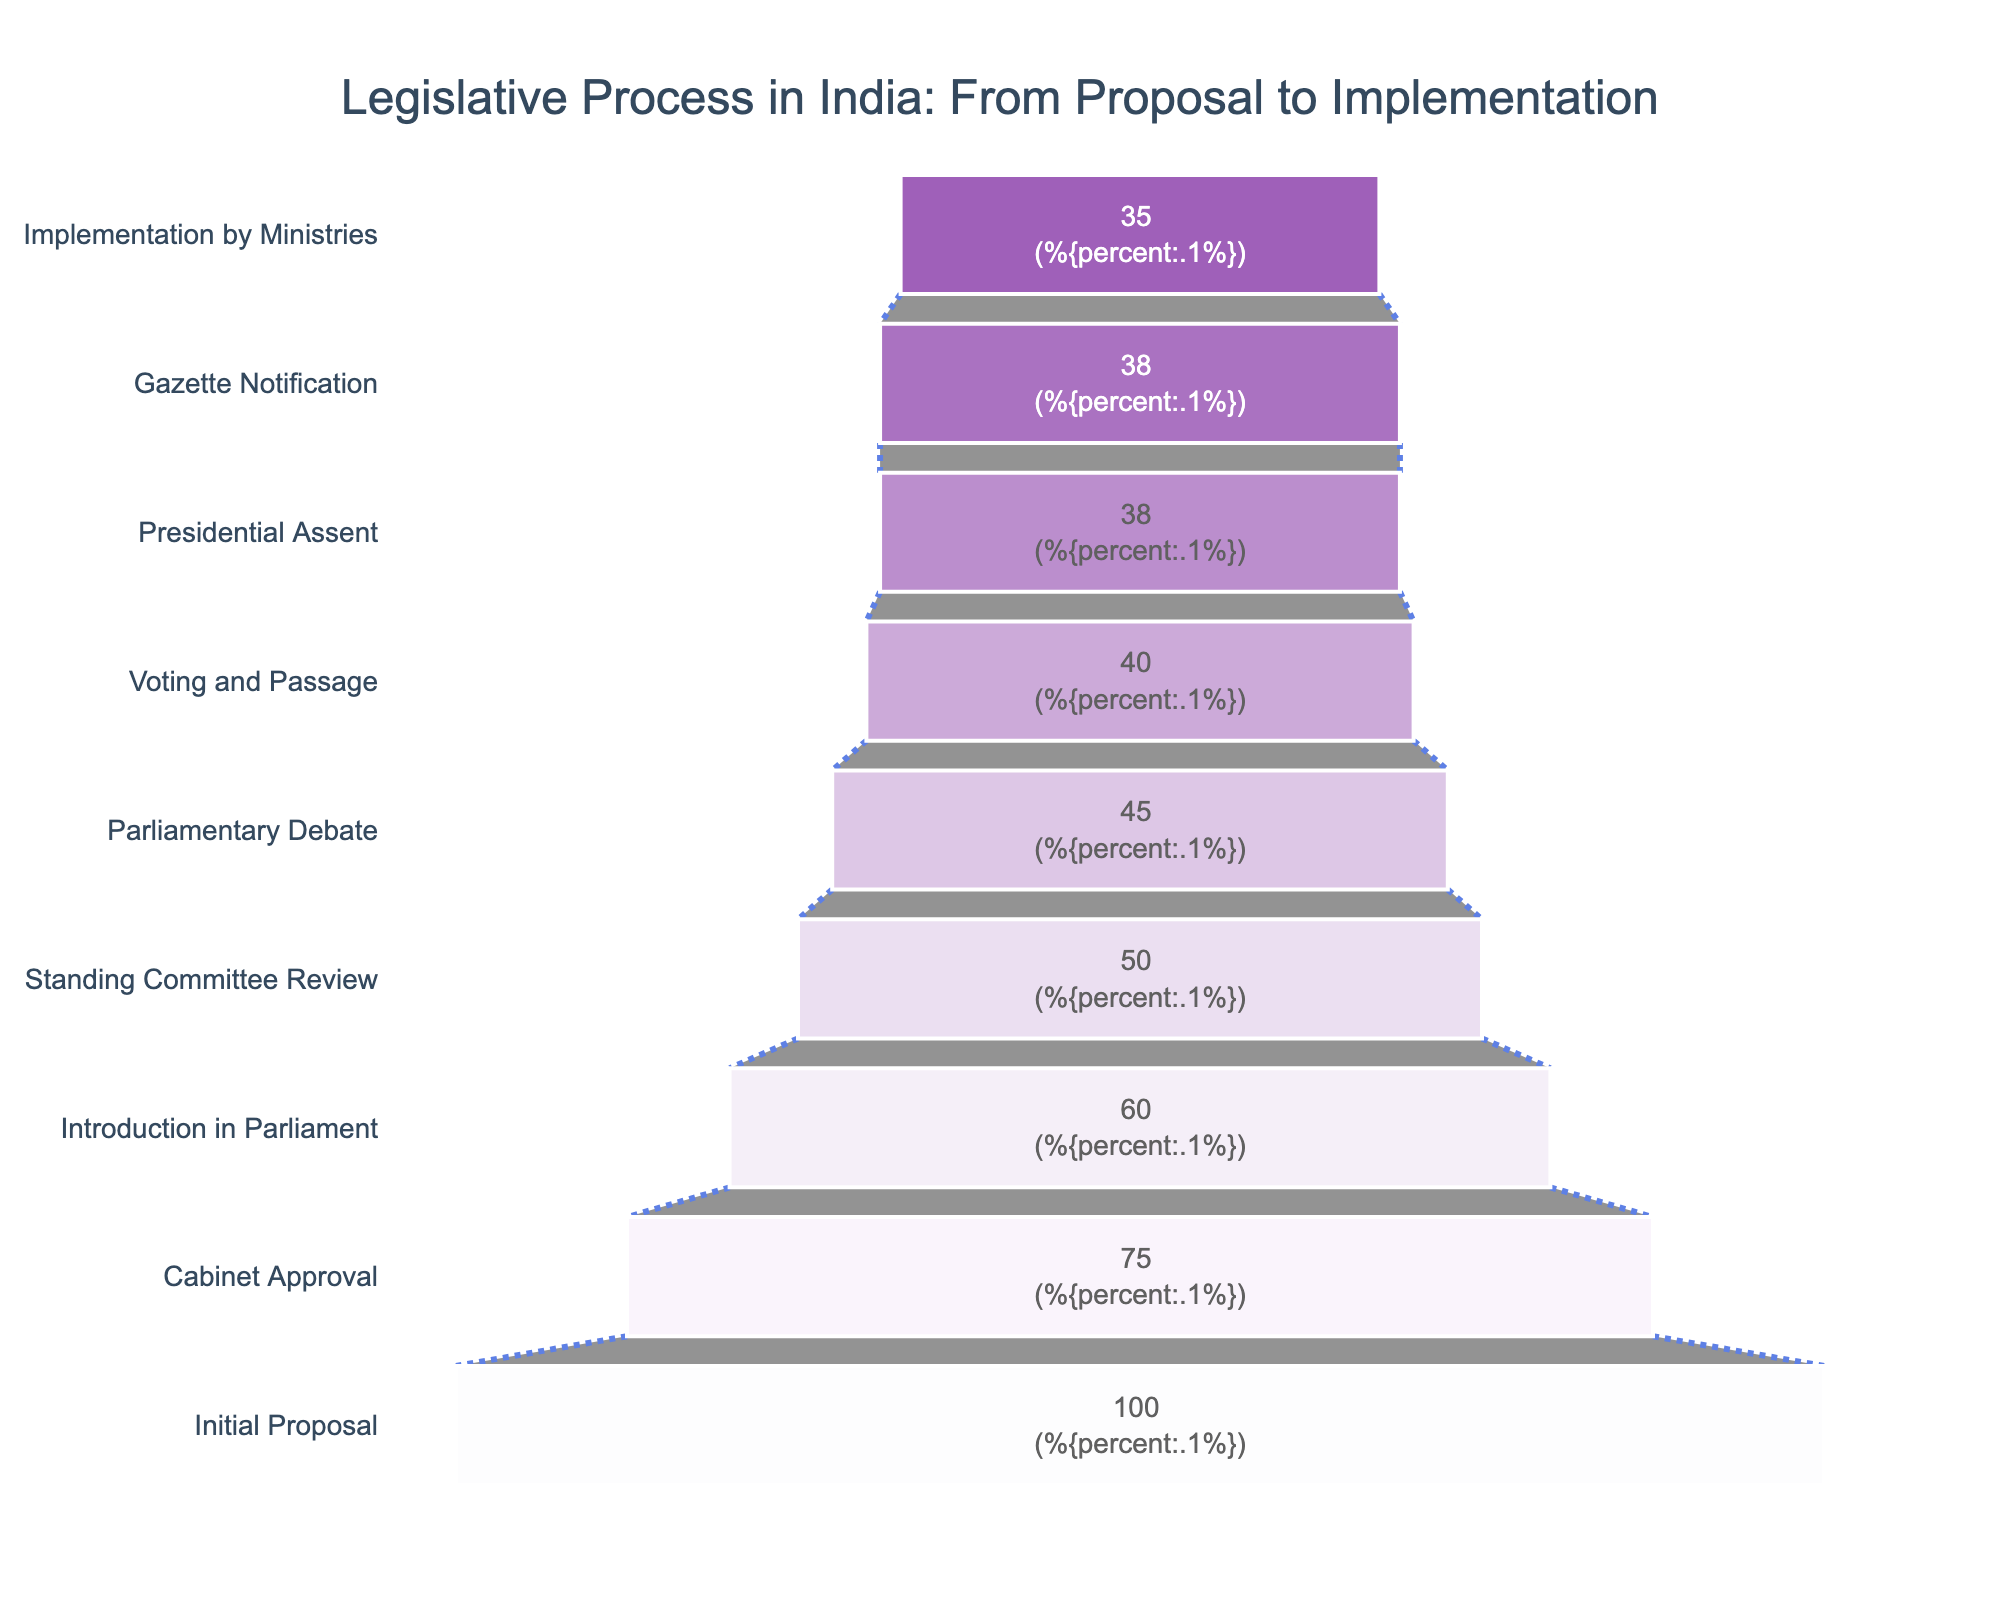What is the title of the chart? The title of the chart is indicated at the top center of the figure. It helps to understand what the chart is about. In this case, it reads "Legislative Process in India: From Proposal to Implementation."
Answer: Legislative Process in India: From Proposal to Implementation How many bills were present at the Initial Proposal stage? To answer this, look at the steps and the number of bills displayed next to each stage on the funnel chart. At the "Initial Proposal" stage, the number is 100.
Answer: 100 What is the final stage displayed in this funnel chart? The final stage is identified as the last entry in the chart, where the legislative process concludes. The final stage shown is "Implementation by Ministries."
Answer: Implementation by Ministries What percentage of bills make it from Initial Proposal to Cabinet Approval? The funnel chart provides both the number of bills and their percentages. To determine the percentage, look for the conversion rate between "Initial Proposal" and "Cabinet Approval." There are 75 bills at the Cabinet Approval stage out of the initial 100, which is 75/100 = 75%.
Answer: 75% Compare the number of bills at the Parliamentary Debate stage to the number at the Voting and Passage stage. Identify the values for both stages in the funnel chart. "Parliamentary Debate" has 45 bills, whereas "Voting and Passage" has 40 bills. Therefore, the Parliamentary Debate stage has more bills.
Answer: Parliamentary Debate has more bills What happens to the number of bills after the Standing Committee Review stage? Follow the sequence of stages after "Standing Committee Review" and compare the numbers. Bills drop from 50 at "Standing Committee Review" to 45 at "Parliamentary Debate." This indicates a reduction of 5 bills.
Answer: Decrease by 5 Which stage sees the highest drop in the number of bills? Calculate the drop in the number of bills between each consecutive stage and identify the largest decrease. Here, the drop from "Initial Proposal" (100 bills) to "Cabinet Approval" (75 bills) is the biggest drop of 25.
Answer: Initial Proposal to Cabinet Approval What percentage of bills that are voted on are eventually enacted through Presidential Assent? Determine the number of bills at "Voting and Passage" (40 bills) and "Presidential Assent" (38 bills). Then, find the percentage: (38/40) * 100% = 95%.
Answer: 95% Between which stages does no change in the number of bills occur? Look for stages that have the same number of bills. Both "Gazette Notification" and "Presidential Assent" have 38 bills, indicating no change between these stages.
Answer: Gazette Notification and Presidential Assent How many bills reach the Implementation by Ministries stage as a percentage of the initial proposals? Calculate the final number of bills at "Implementation by Ministries" (35 bills) as a percentage of initial proposals (100 bills): (35/100) * 100% = 35%.
Answer: 35% 